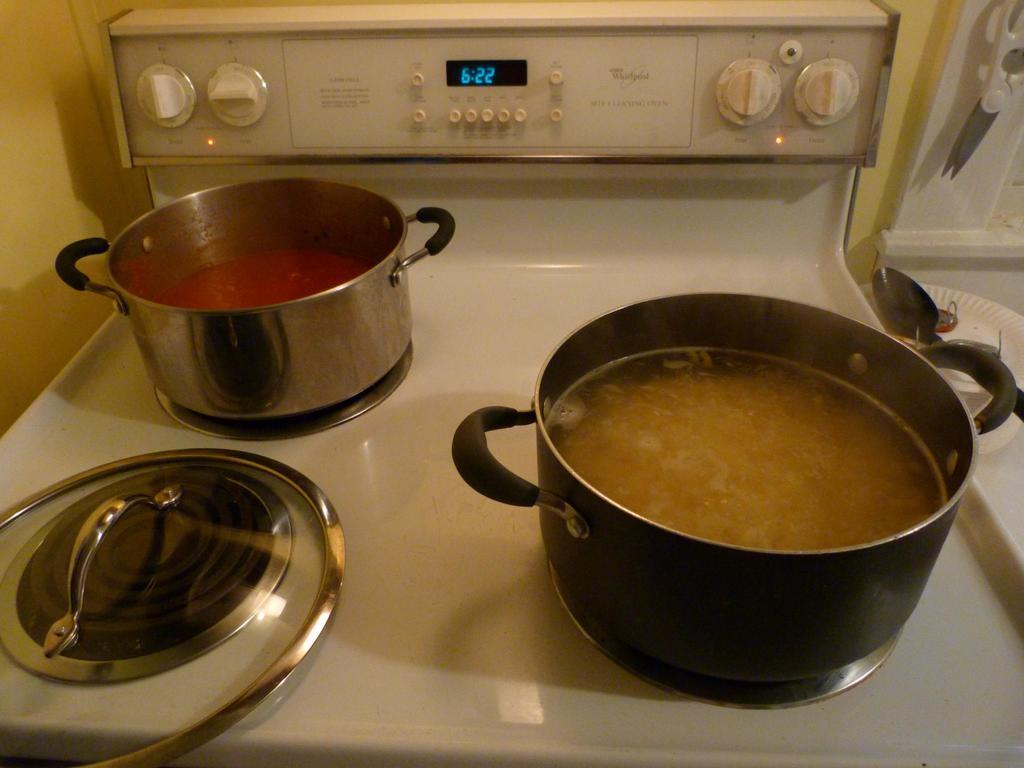<image>
Describe the image concisely. A Whirlpool stove has two cooking pots on top of it with food in them at 6:22. 